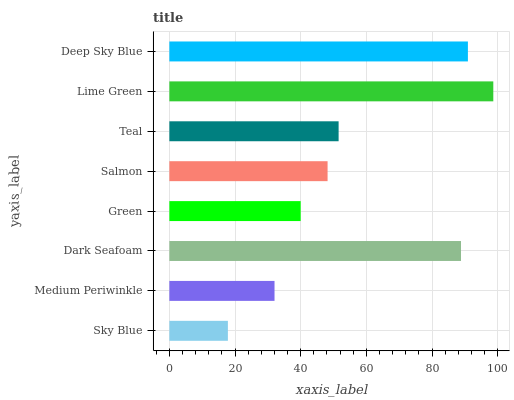Is Sky Blue the minimum?
Answer yes or no. Yes. Is Lime Green the maximum?
Answer yes or no. Yes. Is Medium Periwinkle the minimum?
Answer yes or no. No. Is Medium Periwinkle the maximum?
Answer yes or no. No. Is Medium Periwinkle greater than Sky Blue?
Answer yes or no. Yes. Is Sky Blue less than Medium Periwinkle?
Answer yes or no. Yes. Is Sky Blue greater than Medium Periwinkle?
Answer yes or no. No. Is Medium Periwinkle less than Sky Blue?
Answer yes or no. No. Is Teal the high median?
Answer yes or no. Yes. Is Salmon the low median?
Answer yes or no. Yes. Is Salmon the high median?
Answer yes or no. No. Is Sky Blue the low median?
Answer yes or no. No. 